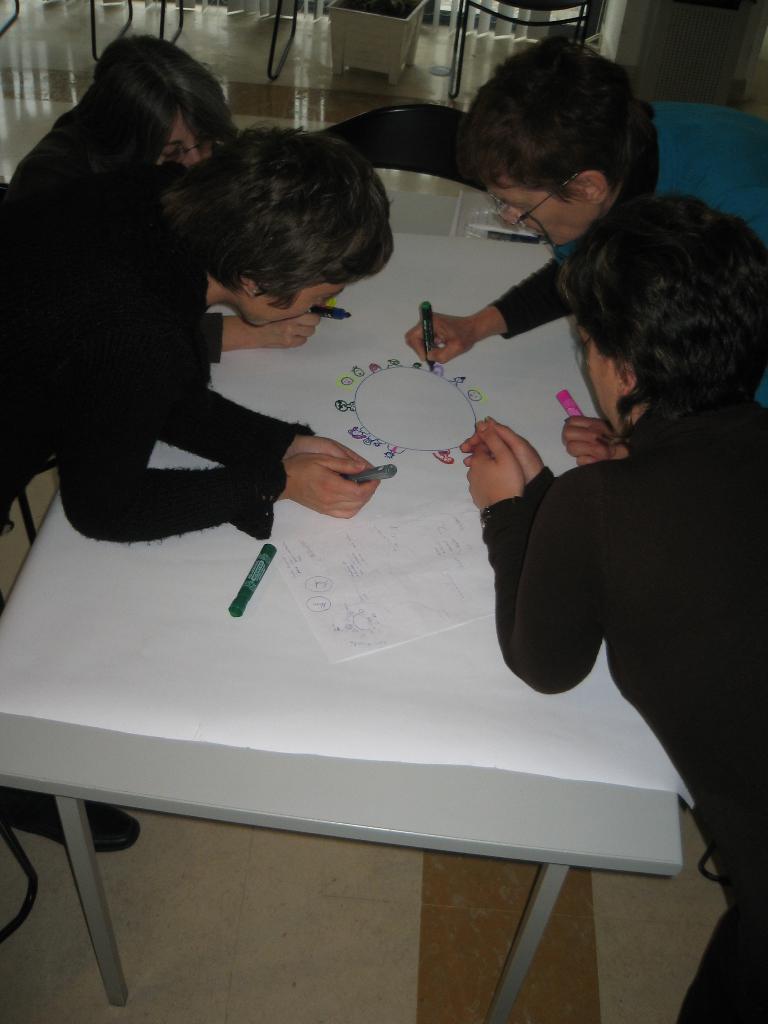How would you summarize this image in a sentence or two? This picture shows four people and a person drawing on the paper on the table 